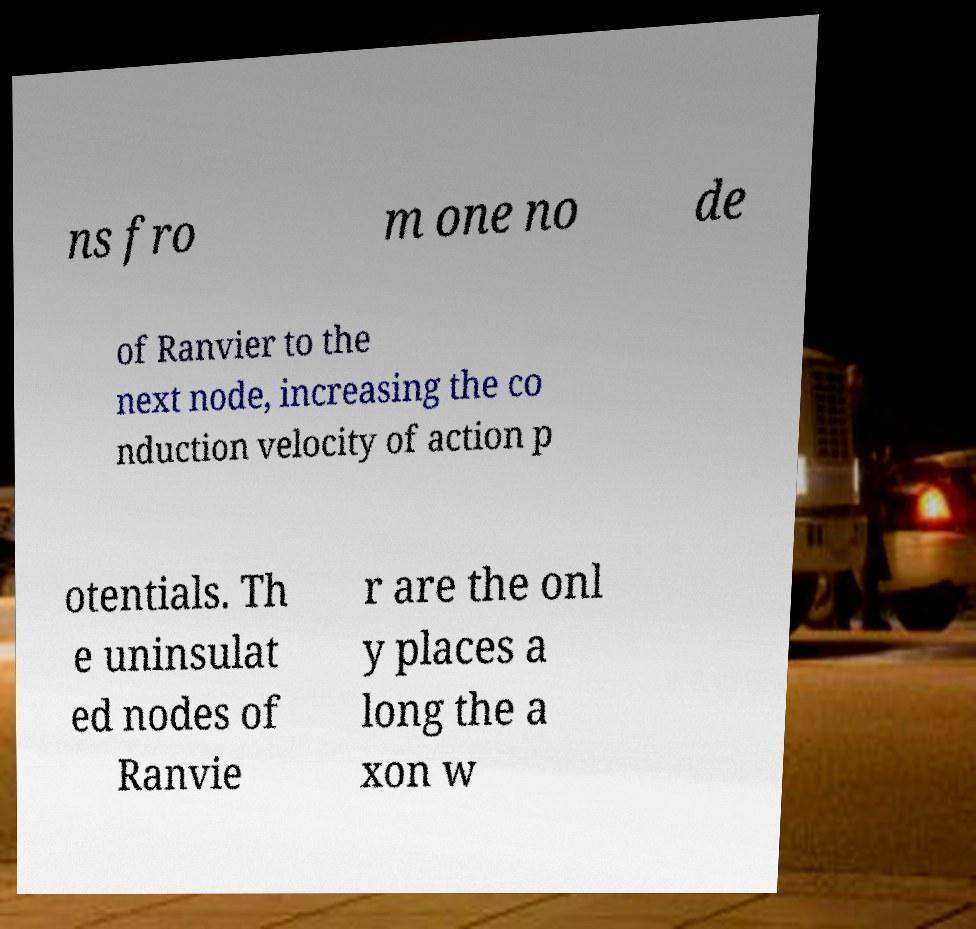Could you extract and type out the text from this image? ns fro m one no de of Ranvier to the next node, increasing the co nduction velocity of action p otentials. Th e uninsulat ed nodes of Ranvie r are the onl y places a long the a xon w 